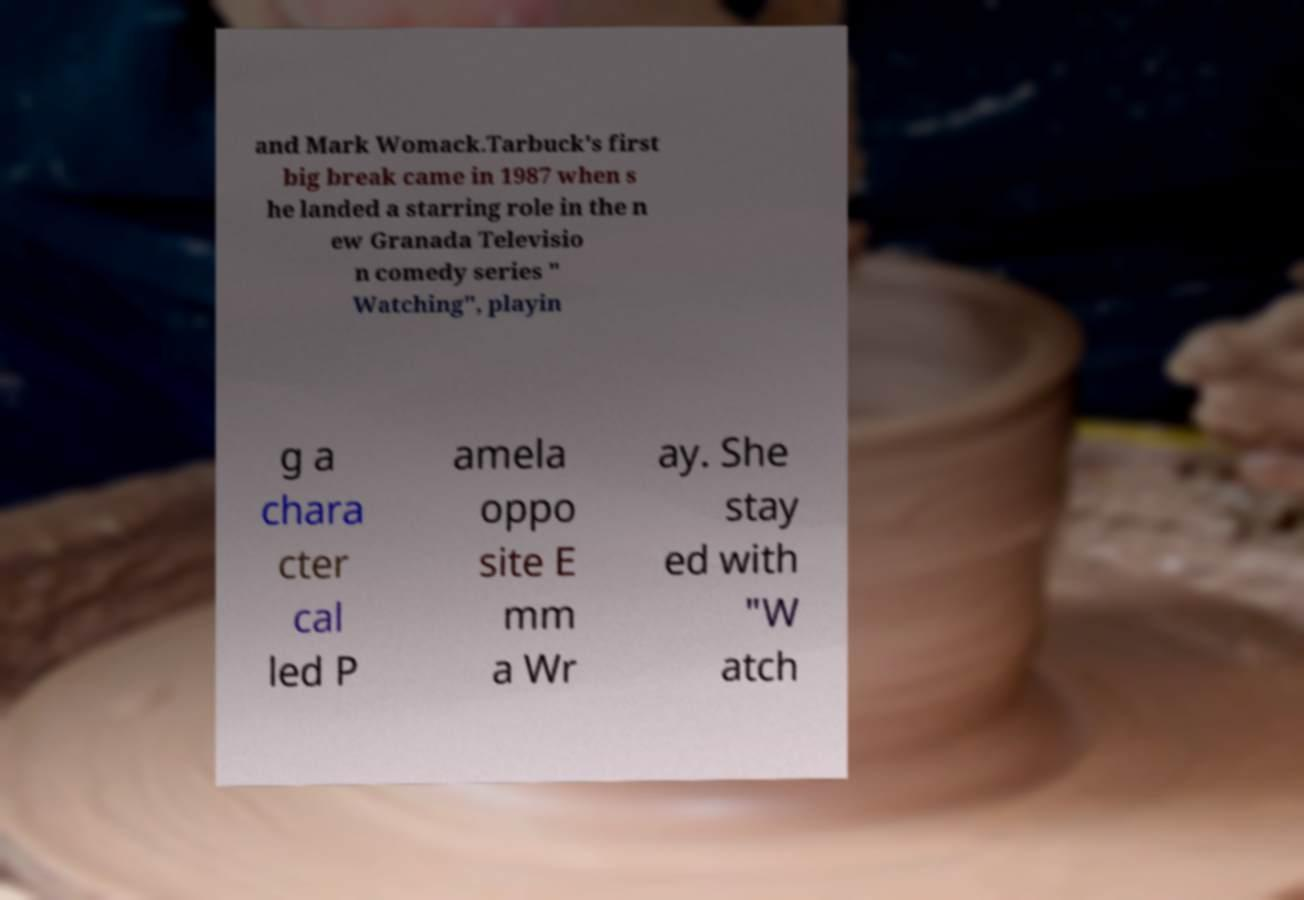Can you read and provide the text displayed in the image?This photo seems to have some interesting text. Can you extract and type it out for me? and Mark Womack.Tarbuck's first big break came in 1987 when s he landed a starring role in the n ew Granada Televisio n comedy series " Watching", playin g a chara cter cal led P amela oppo site E mm a Wr ay. She stay ed with "W atch 